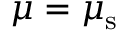Convert formula to latex. <formula><loc_0><loc_0><loc_500><loc_500>\mu = \mu _ { s }</formula> 